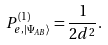<formula> <loc_0><loc_0><loc_500><loc_500>P ^ { ( 1 ) } _ { e , | \Psi _ { A B } \rangle } = \frac { 1 } { 2 d ^ { 2 } } .</formula> 